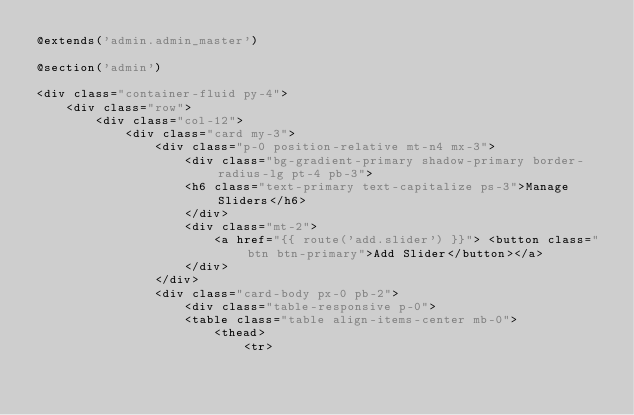<code> <loc_0><loc_0><loc_500><loc_500><_PHP_>@extends('admin.admin_master')

@section('admin')

<div class="container-fluid py-4">
    <div class="row">
        <div class="col-12">
            <div class="card my-3">
                <div class="p-0 position-relative mt-n4 mx-3">
                    <div class="bg-gradient-primary shadow-primary border-radius-lg pt-4 pb-3">
                    <h6 class="text-primary text-capitalize ps-3">Manage Sliders</h6>
                    </div>
                    <div class="mt-2">
                        <a href="{{ route('add.slider') }}"> <button class="btn btn-primary">Add Slider</button></a>
                    </div> 
                </div>
                <div class="card-body px-0 pb-2">
                    <div class="table-responsive p-0">
                    <table class="table align-items-center mb-0">
                        <thead>
                            <tr></code> 